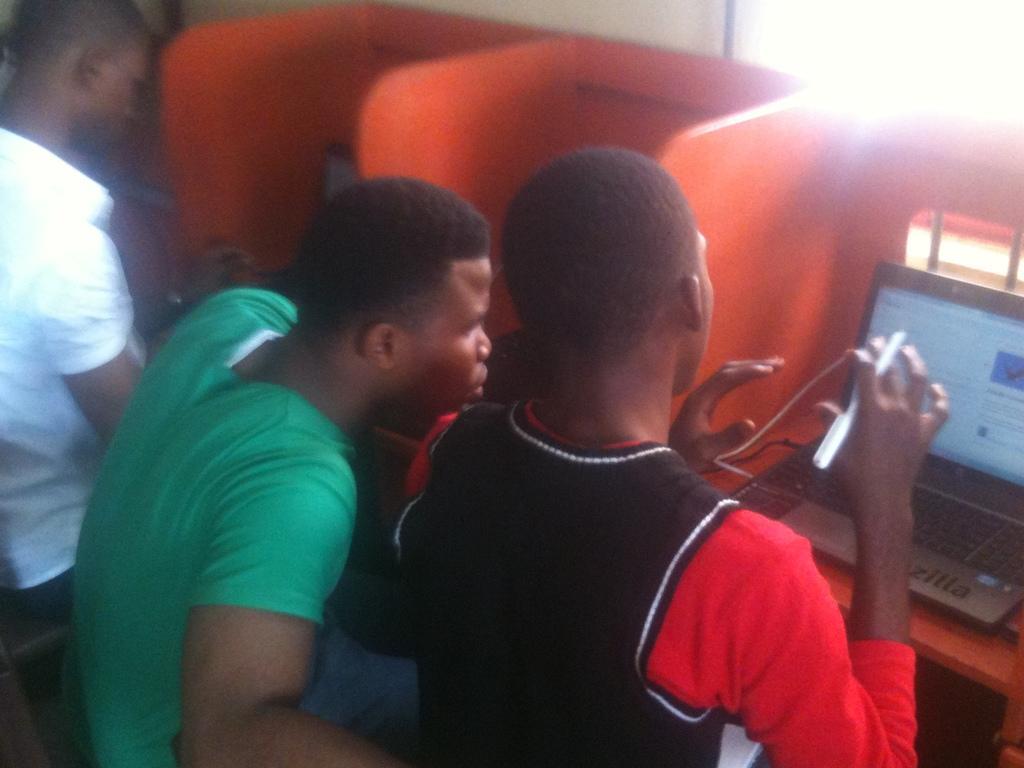How would you summarize this image in a sentence or two? At the bottom of this image, there are two persons in green and black color t-shirts respectively, sitting on a bench. One of them is holding a pen with a hand, in front of a laptop, which is on the table. Beside these two persons, there is a person in a white colored shirt in front of a laptop, which is on the table, which is parted by orange color pads. In the background, there is a light and there is a white color wall. 